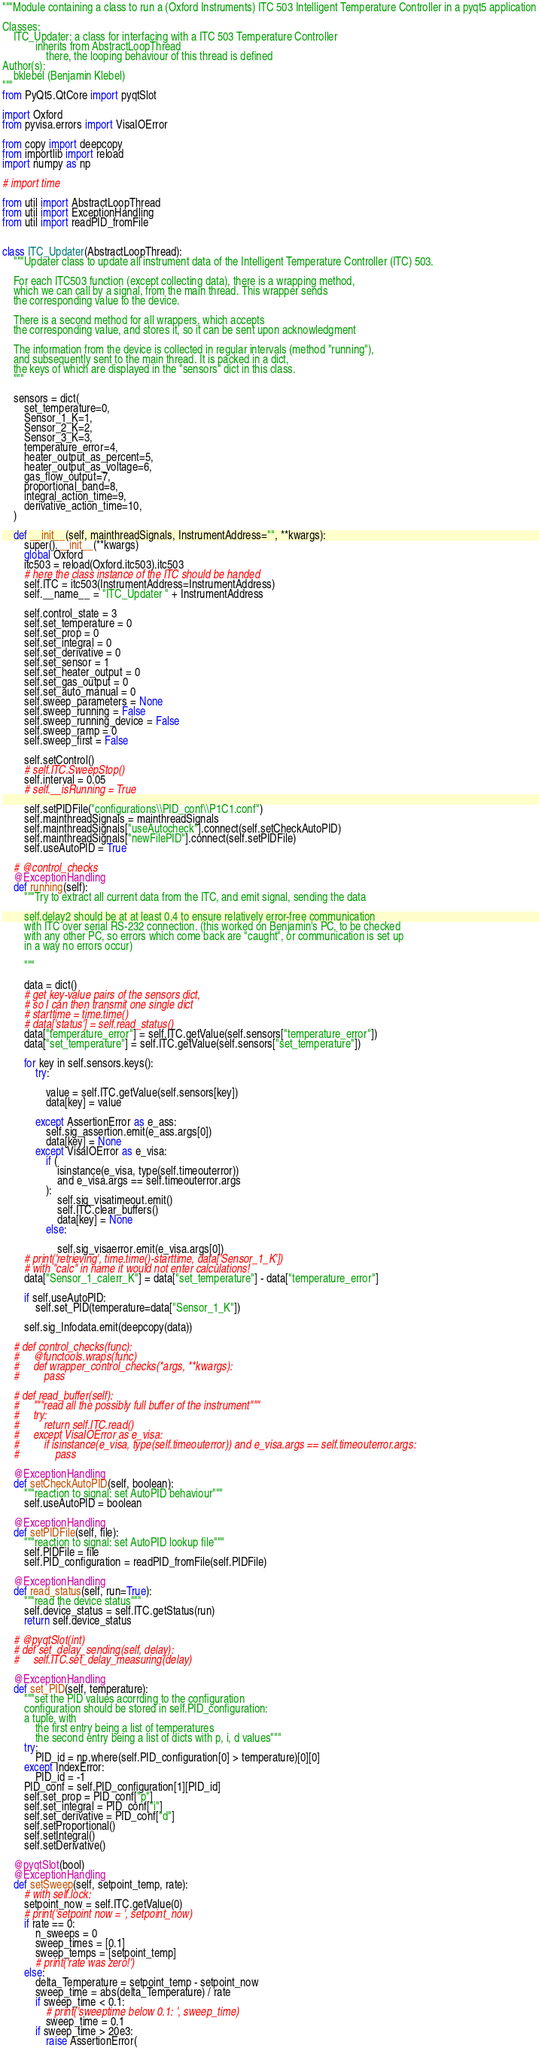<code> <loc_0><loc_0><loc_500><loc_500><_Python_>"""Module containing a class to run a (Oxford Instruments) ITC 503 Intelligent Temperature Controller in a pyqt5 application

Classes:
    ITC_Updater: a class for interfacing with a ITC 503 Temperature Controller
            inherits from AbstractLoopThread
                there, the looping behaviour of this thread is defined
Author(s):
    bklebel (Benjamin Klebel)
"""
from PyQt5.QtCore import pyqtSlot

import Oxford
from pyvisa.errors import VisaIOError

from copy import deepcopy
from importlib import reload
import numpy as np

# import time

from util import AbstractLoopThread
from util import ExceptionHandling
from util import readPID_fromFile


class ITC_Updater(AbstractLoopThread):
    """Updater class to update all instrument data of the Intelligent Temperature Controller (ITC) 503.

    For each ITC503 function (except collecting data), there is a wrapping method,
    which we can call by a signal, from the main thread. This wrapper sends
    the corresponding value to the device.

    There is a second method for all wrappers, which accepts
    the corresponding value, and stores it, so it can be sent upon acknowledgment

    The information from the device is collected in regular intervals (method "running"),
    and subsequently sent to the main thread. It is packed in a dict,
    the keys of which are displayed in the "sensors" dict in this class.
    """

    sensors = dict(
        set_temperature=0,
        Sensor_1_K=1,
        Sensor_2_K=2,
        Sensor_3_K=3,
        temperature_error=4,
        heater_output_as_percent=5,
        heater_output_as_voltage=6,
        gas_flow_output=7,
        proportional_band=8,
        integral_action_time=9,
        derivative_action_time=10,
    )

    def __init__(self, mainthreadSignals, InstrumentAddress="", **kwargs):
        super().__init__(**kwargs)
        global Oxford
        itc503 = reload(Oxford.itc503).itc503
        # here the class instance of the ITC should be handed
        self.ITC = itc503(InstrumentAddress=InstrumentAddress)
        self.__name__ = "ITC_Updater " + InstrumentAddress

        self.control_state = 3
        self.set_temperature = 0
        self.set_prop = 0
        self.set_integral = 0
        self.set_derivative = 0
        self.set_sensor = 1
        self.set_heater_output = 0
        self.set_gas_output = 0
        self.set_auto_manual = 0
        self.sweep_parameters = None
        self.sweep_running = False
        self.sweep_running_device = False
        self.sweep_ramp = 0
        self.sweep_first = False

        self.setControl()
        # self.ITC.SweepStop()
        self.interval = 0.05
        # self.__isRunning = True

        self.setPIDFile("configurations\\PID_conf\\P1C1.conf")
        self.mainthreadSignals = mainthreadSignals
        self.mainthreadSignals["useAutocheck"].connect(self.setCheckAutoPID)
        self.mainthreadSignals["newFilePID"].connect(self.setPIDFile)
        self.useAutoPID = True

    # @control_checks
    @ExceptionHandling
    def running(self):
        """Try to extract all current data from the ITC, and emit signal, sending the data

        self.delay2 should be at at least 0.4 to ensure relatively error-free communication
        with ITC over serial RS-232 connection. (this worked on Benjamin's PC, to be checked
        with any other PC, so errors which come back are "caught", or communication is set up
        in a way no errors occur)

        """

        data = dict()
        # get key-value pairs of the sensors dict,
        # so I can then transmit one single dict
        # starttime = time.time()
        # data['status'] = self.read_status()
        data["temperature_error"] = self.ITC.getValue(self.sensors["temperature_error"])
        data["set_temperature"] = self.ITC.getValue(self.sensors["set_temperature"])

        for key in self.sensors.keys():
            try:

                value = self.ITC.getValue(self.sensors[key])
                data[key] = value

            except AssertionError as e_ass:
                self.sig_assertion.emit(e_ass.args[0])
                data[key] = None
            except VisaIOError as e_visa:
                if (
                    isinstance(e_visa, type(self.timeouterror))
                    and e_visa.args == self.timeouterror.args
                ):
                    self.sig_visatimeout.emit()
                    self.ITC.clear_buffers()
                    data[key] = None
                else:

                    self.sig_visaerror.emit(e_visa.args[0])
        # print('retrieving', time.time()-starttime, data['Sensor_1_K'])
        # with "calc" in name it would not enter calculations!
        data["Sensor_1_calerr_K"] = data["set_temperature"] - data["temperature_error"]

        if self.useAutoPID:
            self.set_PID(temperature=data["Sensor_1_K"])

        self.sig_Infodata.emit(deepcopy(data))

    # def control_checks(func):
    #     @functools.wraps(func)
    #     def wrapper_control_checks(*args, **kwargs):
    #         pass

    # def read_buffer(self):
    #     """read all the possibly full buffer of the instrument"""
    #     try:
    #         return self.ITC.read()
    #     except VisaIOError as e_visa:
    #         if isinstance(e_visa, type(self.timeouterror)) and e_visa.args == self.timeouterror.args:
    #             pass

    @ExceptionHandling
    def setCheckAutoPID(self, boolean):
        """reaction to signal: set AutoPID behaviour"""
        self.useAutoPID = boolean

    @ExceptionHandling
    def setPIDFile(self, file):
        """reaction to signal: set AutoPID lookup file"""
        self.PIDFile = file
        self.PID_configuration = readPID_fromFile(self.PIDFile)

    @ExceptionHandling
    def read_status(self, run=True):
        """read the device status"""
        self.device_status = self.ITC.getStatus(run)
        return self.device_status

    # @pyqtSlot(int)
    # def set_delay_sending(self, delay):
    #     self.ITC.set_delay_measuring(delay)

    @ExceptionHandling
    def set_PID(self, temperature):
        """set the PID values acorrding to the configuration
        configuration should be stored in self.PID_configuration:
        a tuple, with
            the first entry being a list of temperatures
            the second entry being a list of dicts with p, i, d values"""
        try:
            PID_id = np.where(self.PID_configuration[0] > temperature)[0][0]
        except IndexError:
            PID_id = -1
        PID_conf = self.PID_configuration[1][PID_id]
        self.set_prop = PID_conf["p"]
        self.set_integral = PID_conf["i"]
        self.set_derivative = PID_conf["d"]
        self.setProportional()
        self.setIntegral()
        self.setDerivative()

    @pyqtSlot(bool)
    @ExceptionHandling
    def setSweep(self, setpoint_temp, rate):
        # with self.lock:
        setpoint_now = self.ITC.getValue(0)
        # print('setpoint now = ', setpoint_now)
        if rate == 0:
            n_sweeps = 0
            sweep_times = [0.1]
            sweep_temps = [setpoint_temp]
            # print('rate was zero!')
        else:
            delta_Temperature = setpoint_temp - setpoint_now
            sweep_time = abs(delta_Temperature) / rate
            if sweep_time < 0.1:
                # print('sweeptime below 0.1: ', sweep_time)
                sweep_time = 0.1
            if sweep_time > 20e3:
                raise AssertionError(</code> 